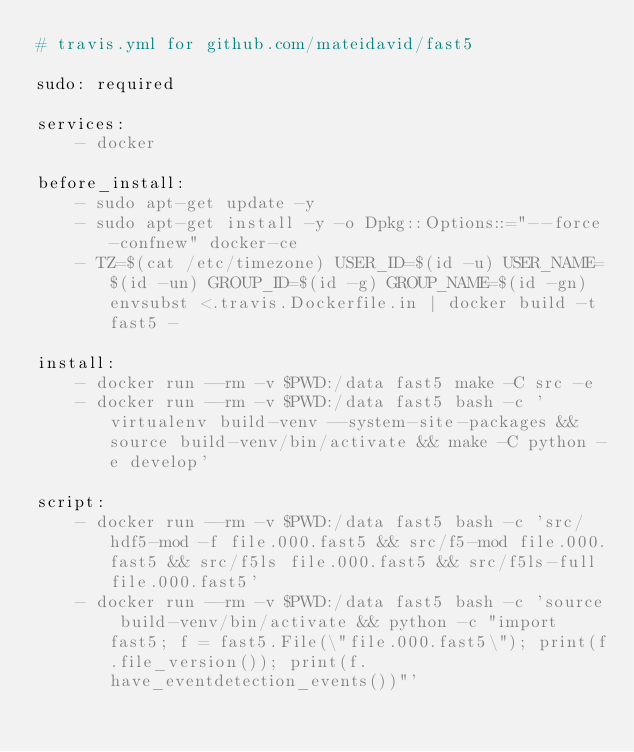<code> <loc_0><loc_0><loc_500><loc_500><_YAML_># travis.yml for github.com/mateidavid/fast5

sudo: required

services:
    - docker

before_install:
    - sudo apt-get update -y
    - sudo apt-get install -y -o Dpkg::Options::="--force-confnew" docker-ce
    - TZ=$(cat /etc/timezone) USER_ID=$(id -u) USER_NAME=$(id -un) GROUP_ID=$(id -g) GROUP_NAME=$(id -gn) envsubst <.travis.Dockerfile.in | docker build -t fast5 -

install:
    - docker run --rm -v $PWD:/data fast5 make -C src -e
    - docker run --rm -v $PWD:/data fast5 bash -c 'virtualenv build-venv --system-site-packages && source build-venv/bin/activate && make -C python -e develop'

script:
    - docker run --rm -v $PWD:/data fast5 bash -c 'src/hdf5-mod -f file.000.fast5 && src/f5-mod file.000.fast5 && src/f5ls file.000.fast5 && src/f5ls-full file.000.fast5'
    - docker run --rm -v $PWD:/data fast5 bash -c 'source build-venv/bin/activate && python -c "import fast5; f = fast5.File(\"file.000.fast5\"); print(f.file_version()); print(f.have_eventdetection_events())"'
</code> 